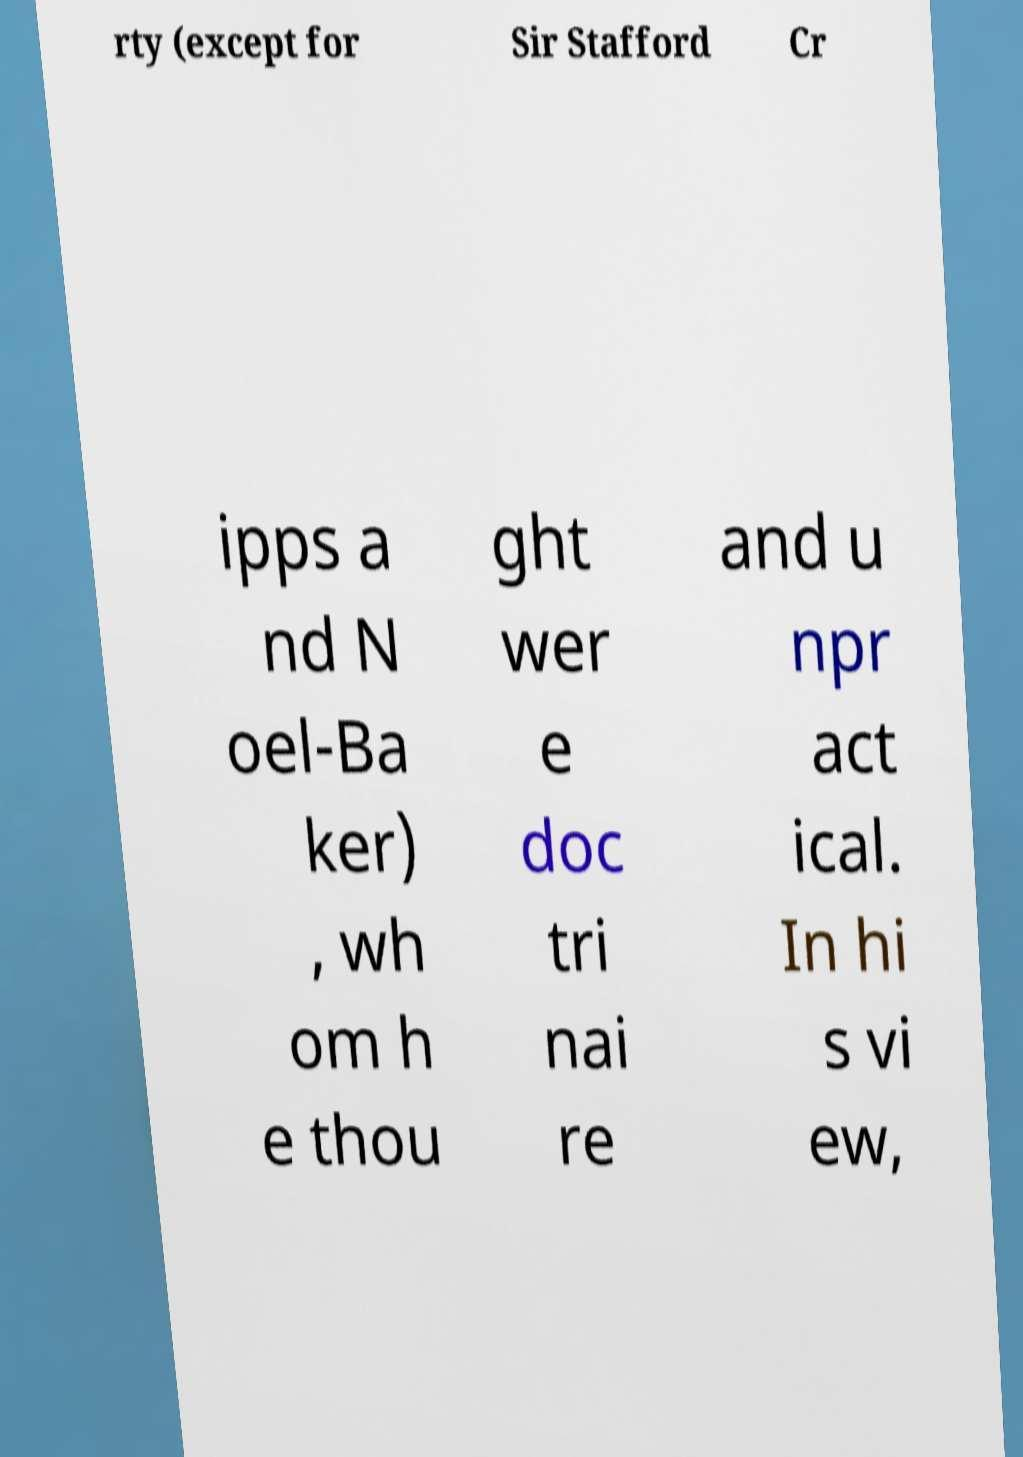Can you accurately transcribe the text from the provided image for me? rty (except for Sir Stafford Cr ipps a nd N oel-Ba ker) , wh om h e thou ght wer e doc tri nai re and u npr act ical. In hi s vi ew, 